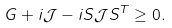<formula> <loc_0><loc_0><loc_500><loc_500>G + i \mathcal { J } - i S \mathcal { J } S ^ { T } \geq 0 .</formula> 